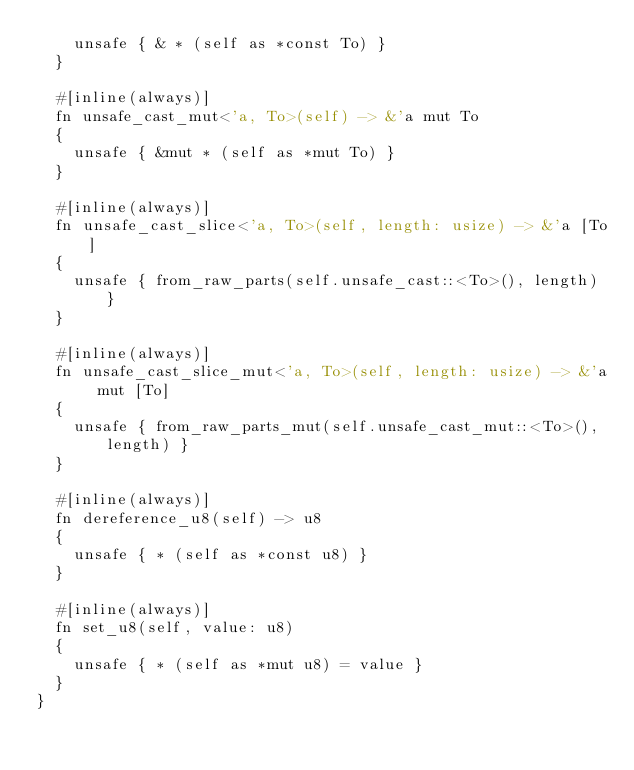<code> <loc_0><loc_0><loc_500><loc_500><_Rust_>		unsafe { & * (self as *const To) }
	}

	#[inline(always)]
	fn unsafe_cast_mut<'a, To>(self) -> &'a mut To
	{
		unsafe { &mut * (self as *mut To) }
	}

	#[inline(always)]
	fn unsafe_cast_slice<'a, To>(self, length: usize) -> &'a [To]
	{
		unsafe { from_raw_parts(self.unsafe_cast::<To>(), length) }
	}

	#[inline(always)]
	fn unsafe_cast_slice_mut<'a, To>(self, length: usize) -> &'a mut [To]
	{
		unsafe { from_raw_parts_mut(self.unsafe_cast_mut::<To>(), length) }
	}

	#[inline(always)]
	fn dereference_u8(self) -> u8
	{
		unsafe { * (self as *const u8) }
	}

	#[inline(always)]
	fn set_u8(self, value: u8)
	{
		unsafe { * (self as *mut u8) = value }
	}
}
</code> 